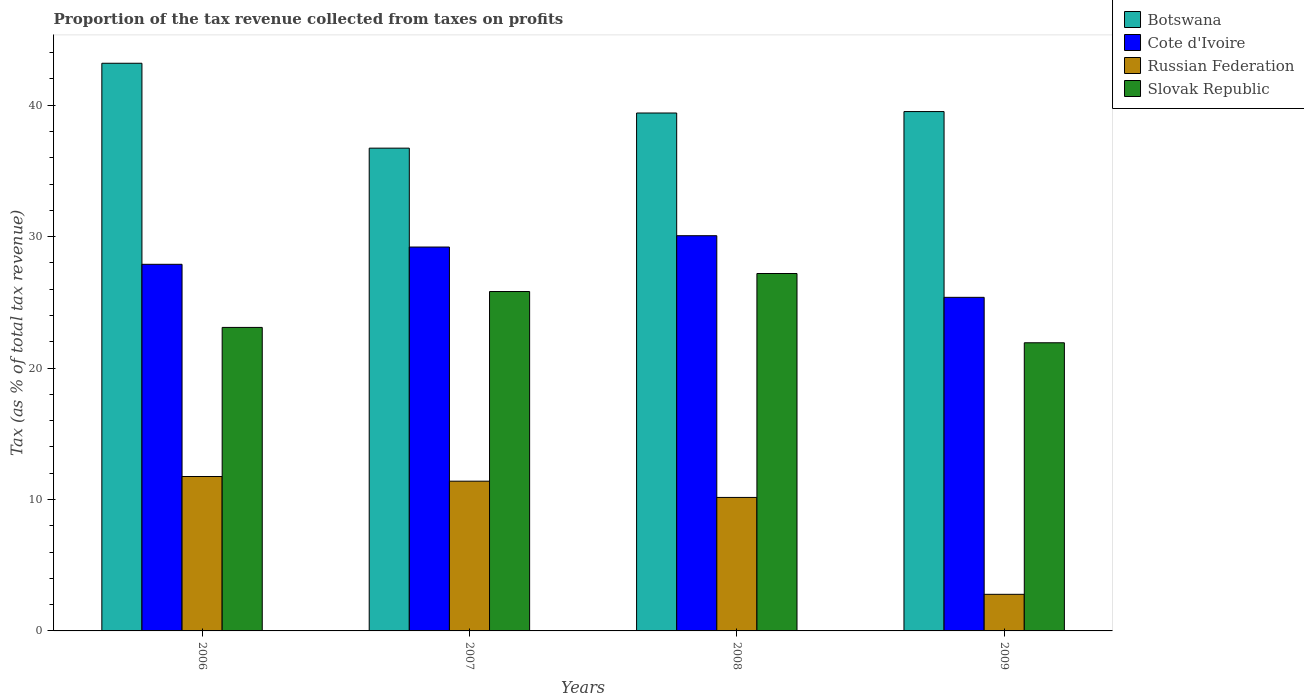How many different coloured bars are there?
Provide a short and direct response. 4. How many groups of bars are there?
Ensure brevity in your answer.  4. How many bars are there on the 3rd tick from the left?
Offer a terse response. 4. How many bars are there on the 1st tick from the right?
Keep it short and to the point. 4. What is the label of the 4th group of bars from the left?
Make the answer very short. 2009. What is the proportion of the tax revenue collected in Cote d'Ivoire in 2006?
Your response must be concise. 27.89. Across all years, what is the maximum proportion of the tax revenue collected in Cote d'Ivoire?
Your answer should be compact. 30.07. Across all years, what is the minimum proportion of the tax revenue collected in Russian Federation?
Provide a succinct answer. 2.78. In which year was the proportion of the tax revenue collected in Cote d'Ivoire maximum?
Offer a terse response. 2008. In which year was the proportion of the tax revenue collected in Slovak Republic minimum?
Provide a succinct answer. 2009. What is the total proportion of the tax revenue collected in Cote d'Ivoire in the graph?
Offer a very short reply. 112.54. What is the difference between the proportion of the tax revenue collected in Slovak Republic in 2008 and that in 2009?
Offer a very short reply. 5.27. What is the difference between the proportion of the tax revenue collected in Cote d'Ivoire in 2007 and the proportion of the tax revenue collected in Slovak Republic in 2006?
Offer a very short reply. 6.11. What is the average proportion of the tax revenue collected in Cote d'Ivoire per year?
Provide a short and direct response. 28.14. In the year 2008, what is the difference between the proportion of the tax revenue collected in Russian Federation and proportion of the tax revenue collected in Slovak Republic?
Your answer should be very brief. -17.04. In how many years, is the proportion of the tax revenue collected in Cote d'Ivoire greater than 32 %?
Provide a succinct answer. 0. What is the ratio of the proportion of the tax revenue collected in Slovak Republic in 2008 to that in 2009?
Provide a short and direct response. 1.24. Is the proportion of the tax revenue collected in Russian Federation in 2006 less than that in 2007?
Provide a short and direct response. No. Is the difference between the proportion of the tax revenue collected in Russian Federation in 2006 and 2007 greater than the difference between the proportion of the tax revenue collected in Slovak Republic in 2006 and 2007?
Your answer should be compact. Yes. What is the difference between the highest and the second highest proportion of the tax revenue collected in Cote d'Ivoire?
Offer a terse response. 0.86. What is the difference between the highest and the lowest proportion of the tax revenue collected in Cote d'Ivoire?
Make the answer very short. 4.69. In how many years, is the proportion of the tax revenue collected in Cote d'Ivoire greater than the average proportion of the tax revenue collected in Cote d'Ivoire taken over all years?
Offer a very short reply. 2. What does the 3rd bar from the left in 2008 represents?
Your answer should be compact. Russian Federation. What does the 2nd bar from the right in 2007 represents?
Your response must be concise. Russian Federation. Is it the case that in every year, the sum of the proportion of the tax revenue collected in Cote d'Ivoire and proportion of the tax revenue collected in Russian Federation is greater than the proportion of the tax revenue collected in Slovak Republic?
Keep it short and to the point. Yes. How many years are there in the graph?
Your answer should be compact. 4. What is the difference between two consecutive major ticks on the Y-axis?
Provide a short and direct response. 10. Are the values on the major ticks of Y-axis written in scientific E-notation?
Ensure brevity in your answer.  No. Does the graph contain grids?
Offer a terse response. No. How are the legend labels stacked?
Keep it short and to the point. Vertical. What is the title of the graph?
Your answer should be compact. Proportion of the tax revenue collected from taxes on profits. Does "Angola" appear as one of the legend labels in the graph?
Give a very brief answer. No. What is the label or title of the Y-axis?
Make the answer very short. Tax (as % of total tax revenue). What is the Tax (as % of total tax revenue) of Botswana in 2006?
Keep it short and to the point. 43.19. What is the Tax (as % of total tax revenue) in Cote d'Ivoire in 2006?
Your answer should be very brief. 27.89. What is the Tax (as % of total tax revenue) of Russian Federation in 2006?
Provide a short and direct response. 11.75. What is the Tax (as % of total tax revenue) of Slovak Republic in 2006?
Your response must be concise. 23.09. What is the Tax (as % of total tax revenue) of Botswana in 2007?
Offer a terse response. 36.73. What is the Tax (as % of total tax revenue) of Cote d'Ivoire in 2007?
Provide a succinct answer. 29.21. What is the Tax (as % of total tax revenue) in Russian Federation in 2007?
Provide a short and direct response. 11.39. What is the Tax (as % of total tax revenue) of Slovak Republic in 2007?
Offer a terse response. 25.82. What is the Tax (as % of total tax revenue) in Botswana in 2008?
Give a very brief answer. 39.4. What is the Tax (as % of total tax revenue) of Cote d'Ivoire in 2008?
Provide a succinct answer. 30.07. What is the Tax (as % of total tax revenue) in Russian Federation in 2008?
Provide a short and direct response. 10.16. What is the Tax (as % of total tax revenue) in Slovak Republic in 2008?
Your answer should be compact. 27.19. What is the Tax (as % of total tax revenue) in Botswana in 2009?
Give a very brief answer. 39.51. What is the Tax (as % of total tax revenue) of Cote d'Ivoire in 2009?
Your response must be concise. 25.38. What is the Tax (as % of total tax revenue) in Russian Federation in 2009?
Provide a short and direct response. 2.78. What is the Tax (as % of total tax revenue) of Slovak Republic in 2009?
Give a very brief answer. 21.92. Across all years, what is the maximum Tax (as % of total tax revenue) of Botswana?
Make the answer very short. 43.19. Across all years, what is the maximum Tax (as % of total tax revenue) of Cote d'Ivoire?
Provide a short and direct response. 30.07. Across all years, what is the maximum Tax (as % of total tax revenue) of Russian Federation?
Offer a very short reply. 11.75. Across all years, what is the maximum Tax (as % of total tax revenue) in Slovak Republic?
Give a very brief answer. 27.19. Across all years, what is the minimum Tax (as % of total tax revenue) in Botswana?
Provide a short and direct response. 36.73. Across all years, what is the minimum Tax (as % of total tax revenue) in Cote d'Ivoire?
Provide a succinct answer. 25.38. Across all years, what is the minimum Tax (as % of total tax revenue) in Russian Federation?
Your answer should be very brief. 2.78. Across all years, what is the minimum Tax (as % of total tax revenue) of Slovak Republic?
Provide a succinct answer. 21.92. What is the total Tax (as % of total tax revenue) in Botswana in the graph?
Provide a succinct answer. 158.83. What is the total Tax (as % of total tax revenue) in Cote d'Ivoire in the graph?
Make the answer very short. 112.54. What is the total Tax (as % of total tax revenue) in Russian Federation in the graph?
Provide a succinct answer. 36.08. What is the total Tax (as % of total tax revenue) of Slovak Republic in the graph?
Your response must be concise. 98.03. What is the difference between the Tax (as % of total tax revenue) of Botswana in 2006 and that in 2007?
Offer a very short reply. 6.46. What is the difference between the Tax (as % of total tax revenue) of Cote d'Ivoire in 2006 and that in 2007?
Offer a terse response. -1.31. What is the difference between the Tax (as % of total tax revenue) of Russian Federation in 2006 and that in 2007?
Ensure brevity in your answer.  0.36. What is the difference between the Tax (as % of total tax revenue) of Slovak Republic in 2006 and that in 2007?
Your answer should be compact. -2.73. What is the difference between the Tax (as % of total tax revenue) in Botswana in 2006 and that in 2008?
Ensure brevity in your answer.  3.78. What is the difference between the Tax (as % of total tax revenue) of Cote d'Ivoire in 2006 and that in 2008?
Ensure brevity in your answer.  -2.18. What is the difference between the Tax (as % of total tax revenue) in Russian Federation in 2006 and that in 2008?
Make the answer very short. 1.59. What is the difference between the Tax (as % of total tax revenue) in Slovak Republic in 2006 and that in 2008?
Offer a terse response. -4.1. What is the difference between the Tax (as % of total tax revenue) of Botswana in 2006 and that in 2009?
Give a very brief answer. 3.68. What is the difference between the Tax (as % of total tax revenue) of Cote d'Ivoire in 2006 and that in 2009?
Your response must be concise. 2.51. What is the difference between the Tax (as % of total tax revenue) in Russian Federation in 2006 and that in 2009?
Make the answer very short. 8.96. What is the difference between the Tax (as % of total tax revenue) of Slovak Republic in 2006 and that in 2009?
Provide a short and direct response. 1.17. What is the difference between the Tax (as % of total tax revenue) in Botswana in 2007 and that in 2008?
Keep it short and to the point. -2.67. What is the difference between the Tax (as % of total tax revenue) of Cote d'Ivoire in 2007 and that in 2008?
Your response must be concise. -0.86. What is the difference between the Tax (as % of total tax revenue) of Russian Federation in 2007 and that in 2008?
Offer a terse response. 1.24. What is the difference between the Tax (as % of total tax revenue) of Slovak Republic in 2007 and that in 2008?
Provide a succinct answer. -1.37. What is the difference between the Tax (as % of total tax revenue) of Botswana in 2007 and that in 2009?
Provide a succinct answer. -2.78. What is the difference between the Tax (as % of total tax revenue) of Cote d'Ivoire in 2007 and that in 2009?
Your response must be concise. 3.83. What is the difference between the Tax (as % of total tax revenue) of Russian Federation in 2007 and that in 2009?
Provide a short and direct response. 8.61. What is the difference between the Tax (as % of total tax revenue) of Slovak Republic in 2007 and that in 2009?
Keep it short and to the point. 3.9. What is the difference between the Tax (as % of total tax revenue) in Botswana in 2008 and that in 2009?
Offer a terse response. -0.11. What is the difference between the Tax (as % of total tax revenue) in Cote d'Ivoire in 2008 and that in 2009?
Your answer should be very brief. 4.69. What is the difference between the Tax (as % of total tax revenue) in Russian Federation in 2008 and that in 2009?
Make the answer very short. 7.37. What is the difference between the Tax (as % of total tax revenue) of Slovak Republic in 2008 and that in 2009?
Keep it short and to the point. 5.27. What is the difference between the Tax (as % of total tax revenue) of Botswana in 2006 and the Tax (as % of total tax revenue) of Cote d'Ivoire in 2007?
Keep it short and to the point. 13.98. What is the difference between the Tax (as % of total tax revenue) of Botswana in 2006 and the Tax (as % of total tax revenue) of Russian Federation in 2007?
Make the answer very short. 31.8. What is the difference between the Tax (as % of total tax revenue) in Botswana in 2006 and the Tax (as % of total tax revenue) in Slovak Republic in 2007?
Make the answer very short. 17.37. What is the difference between the Tax (as % of total tax revenue) of Cote d'Ivoire in 2006 and the Tax (as % of total tax revenue) of Russian Federation in 2007?
Your answer should be very brief. 16.5. What is the difference between the Tax (as % of total tax revenue) in Cote d'Ivoire in 2006 and the Tax (as % of total tax revenue) in Slovak Republic in 2007?
Your answer should be very brief. 2.07. What is the difference between the Tax (as % of total tax revenue) in Russian Federation in 2006 and the Tax (as % of total tax revenue) in Slovak Republic in 2007?
Provide a short and direct response. -14.07. What is the difference between the Tax (as % of total tax revenue) of Botswana in 2006 and the Tax (as % of total tax revenue) of Cote d'Ivoire in 2008?
Your answer should be compact. 13.12. What is the difference between the Tax (as % of total tax revenue) of Botswana in 2006 and the Tax (as % of total tax revenue) of Russian Federation in 2008?
Offer a terse response. 33.03. What is the difference between the Tax (as % of total tax revenue) in Botswana in 2006 and the Tax (as % of total tax revenue) in Slovak Republic in 2008?
Your response must be concise. 16. What is the difference between the Tax (as % of total tax revenue) of Cote d'Ivoire in 2006 and the Tax (as % of total tax revenue) of Russian Federation in 2008?
Give a very brief answer. 17.74. What is the difference between the Tax (as % of total tax revenue) of Cote d'Ivoire in 2006 and the Tax (as % of total tax revenue) of Slovak Republic in 2008?
Ensure brevity in your answer.  0.7. What is the difference between the Tax (as % of total tax revenue) of Russian Federation in 2006 and the Tax (as % of total tax revenue) of Slovak Republic in 2008?
Offer a very short reply. -15.45. What is the difference between the Tax (as % of total tax revenue) in Botswana in 2006 and the Tax (as % of total tax revenue) in Cote d'Ivoire in 2009?
Your answer should be compact. 17.81. What is the difference between the Tax (as % of total tax revenue) in Botswana in 2006 and the Tax (as % of total tax revenue) in Russian Federation in 2009?
Provide a succinct answer. 40.4. What is the difference between the Tax (as % of total tax revenue) of Botswana in 2006 and the Tax (as % of total tax revenue) of Slovak Republic in 2009?
Keep it short and to the point. 21.27. What is the difference between the Tax (as % of total tax revenue) in Cote d'Ivoire in 2006 and the Tax (as % of total tax revenue) in Russian Federation in 2009?
Provide a succinct answer. 25.11. What is the difference between the Tax (as % of total tax revenue) of Cote d'Ivoire in 2006 and the Tax (as % of total tax revenue) of Slovak Republic in 2009?
Your answer should be compact. 5.97. What is the difference between the Tax (as % of total tax revenue) in Russian Federation in 2006 and the Tax (as % of total tax revenue) in Slovak Republic in 2009?
Your answer should be very brief. -10.18. What is the difference between the Tax (as % of total tax revenue) of Botswana in 2007 and the Tax (as % of total tax revenue) of Cote d'Ivoire in 2008?
Provide a succinct answer. 6.66. What is the difference between the Tax (as % of total tax revenue) of Botswana in 2007 and the Tax (as % of total tax revenue) of Russian Federation in 2008?
Ensure brevity in your answer.  26.57. What is the difference between the Tax (as % of total tax revenue) in Botswana in 2007 and the Tax (as % of total tax revenue) in Slovak Republic in 2008?
Offer a terse response. 9.54. What is the difference between the Tax (as % of total tax revenue) in Cote d'Ivoire in 2007 and the Tax (as % of total tax revenue) in Russian Federation in 2008?
Offer a terse response. 19.05. What is the difference between the Tax (as % of total tax revenue) in Cote d'Ivoire in 2007 and the Tax (as % of total tax revenue) in Slovak Republic in 2008?
Give a very brief answer. 2.01. What is the difference between the Tax (as % of total tax revenue) of Russian Federation in 2007 and the Tax (as % of total tax revenue) of Slovak Republic in 2008?
Provide a succinct answer. -15.8. What is the difference between the Tax (as % of total tax revenue) of Botswana in 2007 and the Tax (as % of total tax revenue) of Cote d'Ivoire in 2009?
Provide a short and direct response. 11.35. What is the difference between the Tax (as % of total tax revenue) of Botswana in 2007 and the Tax (as % of total tax revenue) of Russian Federation in 2009?
Provide a succinct answer. 33.95. What is the difference between the Tax (as % of total tax revenue) of Botswana in 2007 and the Tax (as % of total tax revenue) of Slovak Republic in 2009?
Offer a very short reply. 14.81. What is the difference between the Tax (as % of total tax revenue) in Cote d'Ivoire in 2007 and the Tax (as % of total tax revenue) in Russian Federation in 2009?
Keep it short and to the point. 26.42. What is the difference between the Tax (as % of total tax revenue) of Cote d'Ivoire in 2007 and the Tax (as % of total tax revenue) of Slovak Republic in 2009?
Make the answer very short. 7.28. What is the difference between the Tax (as % of total tax revenue) in Russian Federation in 2007 and the Tax (as % of total tax revenue) in Slovak Republic in 2009?
Offer a terse response. -10.53. What is the difference between the Tax (as % of total tax revenue) in Botswana in 2008 and the Tax (as % of total tax revenue) in Cote d'Ivoire in 2009?
Offer a very short reply. 14.02. What is the difference between the Tax (as % of total tax revenue) in Botswana in 2008 and the Tax (as % of total tax revenue) in Russian Federation in 2009?
Offer a terse response. 36.62. What is the difference between the Tax (as % of total tax revenue) of Botswana in 2008 and the Tax (as % of total tax revenue) of Slovak Republic in 2009?
Your answer should be compact. 17.48. What is the difference between the Tax (as % of total tax revenue) in Cote d'Ivoire in 2008 and the Tax (as % of total tax revenue) in Russian Federation in 2009?
Your answer should be compact. 27.28. What is the difference between the Tax (as % of total tax revenue) of Cote d'Ivoire in 2008 and the Tax (as % of total tax revenue) of Slovak Republic in 2009?
Your response must be concise. 8.14. What is the difference between the Tax (as % of total tax revenue) in Russian Federation in 2008 and the Tax (as % of total tax revenue) in Slovak Republic in 2009?
Provide a short and direct response. -11.77. What is the average Tax (as % of total tax revenue) in Botswana per year?
Your answer should be very brief. 39.71. What is the average Tax (as % of total tax revenue) in Cote d'Ivoire per year?
Offer a very short reply. 28.14. What is the average Tax (as % of total tax revenue) of Russian Federation per year?
Offer a terse response. 9.02. What is the average Tax (as % of total tax revenue) of Slovak Republic per year?
Keep it short and to the point. 24.51. In the year 2006, what is the difference between the Tax (as % of total tax revenue) in Botswana and Tax (as % of total tax revenue) in Cote d'Ivoire?
Provide a short and direct response. 15.3. In the year 2006, what is the difference between the Tax (as % of total tax revenue) of Botswana and Tax (as % of total tax revenue) of Russian Federation?
Provide a succinct answer. 31.44. In the year 2006, what is the difference between the Tax (as % of total tax revenue) in Botswana and Tax (as % of total tax revenue) in Slovak Republic?
Your response must be concise. 20.1. In the year 2006, what is the difference between the Tax (as % of total tax revenue) in Cote d'Ivoire and Tax (as % of total tax revenue) in Russian Federation?
Ensure brevity in your answer.  16.14. In the year 2006, what is the difference between the Tax (as % of total tax revenue) in Cote d'Ivoire and Tax (as % of total tax revenue) in Slovak Republic?
Give a very brief answer. 4.8. In the year 2006, what is the difference between the Tax (as % of total tax revenue) of Russian Federation and Tax (as % of total tax revenue) of Slovak Republic?
Your answer should be very brief. -11.34. In the year 2007, what is the difference between the Tax (as % of total tax revenue) of Botswana and Tax (as % of total tax revenue) of Cote d'Ivoire?
Your answer should be compact. 7.52. In the year 2007, what is the difference between the Tax (as % of total tax revenue) in Botswana and Tax (as % of total tax revenue) in Russian Federation?
Offer a very short reply. 25.34. In the year 2007, what is the difference between the Tax (as % of total tax revenue) of Botswana and Tax (as % of total tax revenue) of Slovak Republic?
Provide a succinct answer. 10.91. In the year 2007, what is the difference between the Tax (as % of total tax revenue) of Cote d'Ivoire and Tax (as % of total tax revenue) of Russian Federation?
Keep it short and to the point. 17.81. In the year 2007, what is the difference between the Tax (as % of total tax revenue) in Cote d'Ivoire and Tax (as % of total tax revenue) in Slovak Republic?
Your answer should be very brief. 3.38. In the year 2007, what is the difference between the Tax (as % of total tax revenue) in Russian Federation and Tax (as % of total tax revenue) in Slovak Republic?
Your answer should be compact. -14.43. In the year 2008, what is the difference between the Tax (as % of total tax revenue) in Botswana and Tax (as % of total tax revenue) in Cote d'Ivoire?
Your response must be concise. 9.34. In the year 2008, what is the difference between the Tax (as % of total tax revenue) in Botswana and Tax (as % of total tax revenue) in Russian Federation?
Your answer should be compact. 29.25. In the year 2008, what is the difference between the Tax (as % of total tax revenue) in Botswana and Tax (as % of total tax revenue) in Slovak Republic?
Give a very brief answer. 12.21. In the year 2008, what is the difference between the Tax (as % of total tax revenue) of Cote d'Ivoire and Tax (as % of total tax revenue) of Russian Federation?
Provide a short and direct response. 19.91. In the year 2008, what is the difference between the Tax (as % of total tax revenue) in Cote d'Ivoire and Tax (as % of total tax revenue) in Slovak Republic?
Keep it short and to the point. 2.87. In the year 2008, what is the difference between the Tax (as % of total tax revenue) of Russian Federation and Tax (as % of total tax revenue) of Slovak Republic?
Your answer should be very brief. -17.04. In the year 2009, what is the difference between the Tax (as % of total tax revenue) in Botswana and Tax (as % of total tax revenue) in Cote d'Ivoire?
Your answer should be very brief. 14.13. In the year 2009, what is the difference between the Tax (as % of total tax revenue) of Botswana and Tax (as % of total tax revenue) of Russian Federation?
Ensure brevity in your answer.  36.73. In the year 2009, what is the difference between the Tax (as % of total tax revenue) of Botswana and Tax (as % of total tax revenue) of Slovak Republic?
Offer a terse response. 17.59. In the year 2009, what is the difference between the Tax (as % of total tax revenue) in Cote d'Ivoire and Tax (as % of total tax revenue) in Russian Federation?
Your answer should be very brief. 22.59. In the year 2009, what is the difference between the Tax (as % of total tax revenue) in Cote d'Ivoire and Tax (as % of total tax revenue) in Slovak Republic?
Make the answer very short. 3.46. In the year 2009, what is the difference between the Tax (as % of total tax revenue) of Russian Federation and Tax (as % of total tax revenue) of Slovak Republic?
Make the answer very short. -19.14. What is the ratio of the Tax (as % of total tax revenue) in Botswana in 2006 to that in 2007?
Offer a very short reply. 1.18. What is the ratio of the Tax (as % of total tax revenue) in Cote d'Ivoire in 2006 to that in 2007?
Offer a very short reply. 0.95. What is the ratio of the Tax (as % of total tax revenue) in Russian Federation in 2006 to that in 2007?
Make the answer very short. 1.03. What is the ratio of the Tax (as % of total tax revenue) of Slovak Republic in 2006 to that in 2007?
Give a very brief answer. 0.89. What is the ratio of the Tax (as % of total tax revenue) in Botswana in 2006 to that in 2008?
Make the answer very short. 1.1. What is the ratio of the Tax (as % of total tax revenue) of Cote d'Ivoire in 2006 to that in 2008?
Your response must be concise. 0.93. What is the ratio of the Tax (as % of total tax revenue) of Russian Federation in 2006 to that in 2008?
Offer a very short reply. 1.16. What is the ratio of the Tax (as % of total tax revenue) in Slovak Republic in 2006 to that in 2008?
Give a very brief answer. 0.85. What is the ratio of the Tax (as % of total tax revenue) of Botswana in 2006 to that in 2009?
Your response must be concise. 1.09. What is the ratio of the Tax (as % of total tax revenue) in Cote d'Ivoire in 2006 to that in 2009?
Keep it short and to the point. 1.1. What is the ratio of the Tax (as % of total tax revenue) in Russian Federation in 2006 to that in 2009?
Ensure brevity in your answer.  4.22. What is the ratio of the Tax (as % of total tax revenue) of Slovak Republic in 2006 to that in 2009?
Ensure brevity in your answer.  1.05. What is the ratio of the Tax (as % of total tax revenue) of Botswana in 2007 to that in 2008?
Make the answer very short. 0.93. What is the ratio of the Tax (as % of total tax revenue) of Cote d'Ivoire in 2007 to that in 2008?
Your response must be concise. 0.97. What is the ratio of the Tax (as % of total tax revenue) of Russian Federation in 2007 to that in 2008?
Offer a terse response. 1.12. What is the ratio of the Tax (as % of total tax revenue) in Slovak Republic in 2007 to that in 2008?
Make the answer very short. 0.95. What is the ratio of the Tax (as % of total tax revenue) in Botswana in 2007 to that in 2009?
Give a very brief answer. 0.93. What is the ratio of the Tax (as % of total tax revenue) in Cote d'Ivoire in 2007 to that in 2009?
Your answer should be very brief. 1.15. What is the ratio of the Tax (as % of total tax revenue) of Russian Federation in 2007 to that in 2009?
Make the answer very short. 4.09. What is the ratio of the Tax (as % of total tax revenue) of Slovak Republic in 2007 to that in 2009?
Your response must be concise. 1.18. What is the ratio of the Tax (as % of total tax revenue) in Botswana in 2008 to that in 2009?
Offer a very short reply. 1. What is the ratio of the Tax (as % of total tax revenue) in Cote d'Ivoire in 2008 to that in 2009?
Give a very brief answer. 1.18. What is the ratio of the Tax (as % of total tax revenue) of Russian Federation in 2008 to that in 2009?
Provide a succinct answer. 3.65. What is the ratio of the Tax (as % of total tax revenue) in Slovak Republic in 2008 to that in 2009?
Your answer should be very brief. 1.24. What is the difference between the highest and the second highest Tax (as % of total tax revenue) in Botswana?
Your response must be concise. 3.68. What is the difference between the highest and the second highest Tax (as % of total tax revenue) of Cote d'Ivoire?
Give a very brief answer. 0.86. What is the difference between the highest and the second highest Tax (as % of total tax revenue) in Russian Federation?
Your answer should be very brief. 0.36. What is the difference between the highest and the second highest Tax (as % of total tax revenue) in Slovak Republic?
Make the answer very short. 1.37. What is the difference between the highest and the lowest Tax (as % of total tax revenue) of Botswana?
Offer a terse response. 6.46. What is the difference between the highest and the lowest Tax (as % of total tax revenue) in Cote d'Ivoire?
Provide a short and direct response. 4.69. What is the difference between the highest and the lowest Tax (as % of total tax revenue) of Russian Federation?
Offer a very short reply. 8.96. What is the difference between the highest and the lowest Tax (as % of total tax revenue) in Slovak Republic?
Provide a short and direct response. 5.27. 